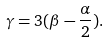Convert formula to latex. <formula><loc_0><loc_0><loc_500><loc_500>\gamma = 3 ( \beta - \frac { \alpha } { 2 } ) .</formula> 